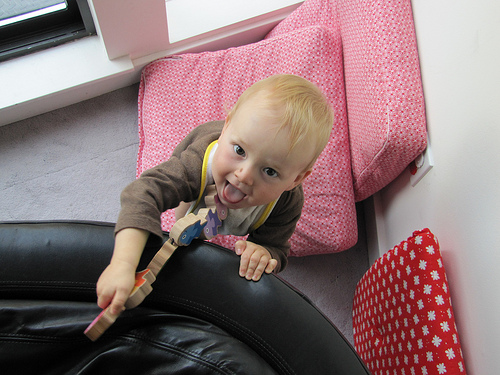<image>
Is there a child behind the sofa? Yes. From this viewpoint, the child is positioned behind the sofa, with the sofa partially or fully occluding the child. Is there a boy on the pillow? Yes. Looking at the image, I can see the boy is positioned on top of the pillow, with the pillow providing support. Is the baby in front of the couch pillow? Yes. The baby is positioned in front of the couch pillow, appearing closer to the camera viewpoint. 